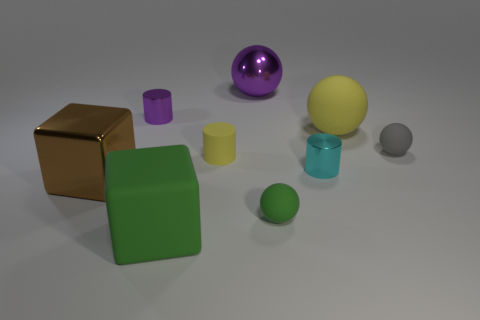Do the ball in front of the gray sphere and the yellow cylinder have the same size?
Provide a short and direct response. Yes. There is a ball that is the same color as the large matte block; what is its size?
Your answer should be very brief. Small. Are there any balls that have the same size as the brown cube?
Provide a succinct answer. Yes. There is a large rubber object that is in front of the cyan thing; is its color the same as the tiny rubber sphere that is in front of the yellow matte cylinder?
Offer a very short reply. Yes. Are there any rubber things of the same color as the big rubber sphere?
Ensure brevity in your answer.  Yes. What number of other things are there of the same shape as the tiny yellow object?
Your answer should be very brief. 2. What shape is the purple object behind the small purple shiny object?
Your answer should be very brief. Sphere. Is the shape of the tiny yellow object the same as the small shiny object in front of the tiny purple shiny cylinder?
Provide a short and direct response. Yes. How big is the shiny thing that is both on the left side of the tiny yellow object and behind the big matte sphere?
Your answer should be compact. Small. There is a object that is to the left of the tiny gray sphere and right of the tiny cyan shiny object; what color is it?
Offer a very short reply. Yellow. 